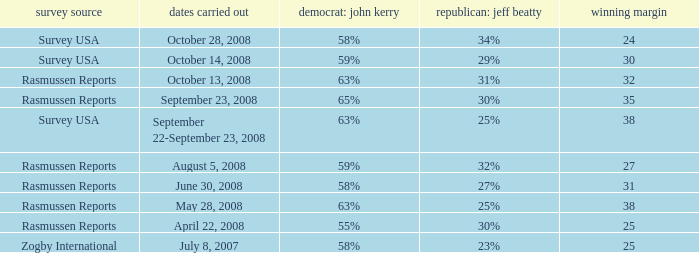Who is the poll source that has Republican: Jeff Beatty behind at 27%? Rasmussen Reports. 